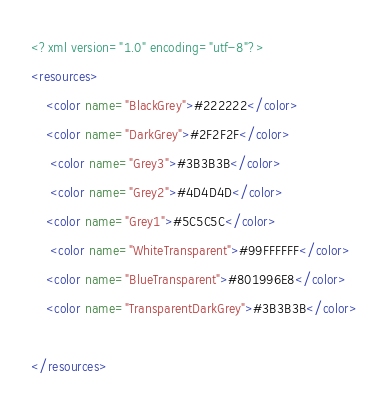Convert code to text. <code><loc_0><loc_0><loc_500><loc_500><_XML_><?xml version="1.0" encoding="utf-8"?>
<resources>
    <color name="BlackGrey">#222222</color>
    <color name="DarkGrey">#2F2F2F</color>
     <color name="Grey3">#3B3B3B</color>
     <color name="Grey2">#4D4D4D</color>
    <color name="Grey1">#5C5C5C</color>
     <color name="WhiteTransparent">#99FFFFFF</color>
    <color name="BlueTransparent">#801996E8</color>
    <color name="TransparentDarkGrey">#3B3B3B</color>
    
</resources>
</code> 